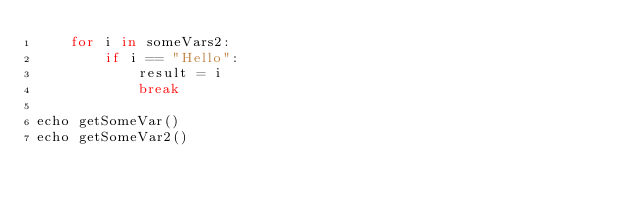Convert code to text. <code><loc_0><loc_0><loc_500><loc_500><_Nim_>    for i in someVars2:
        if i == "Hello":
            result = i
            break

echo getSomeVar()
echo getSomeVar2()
</code> 